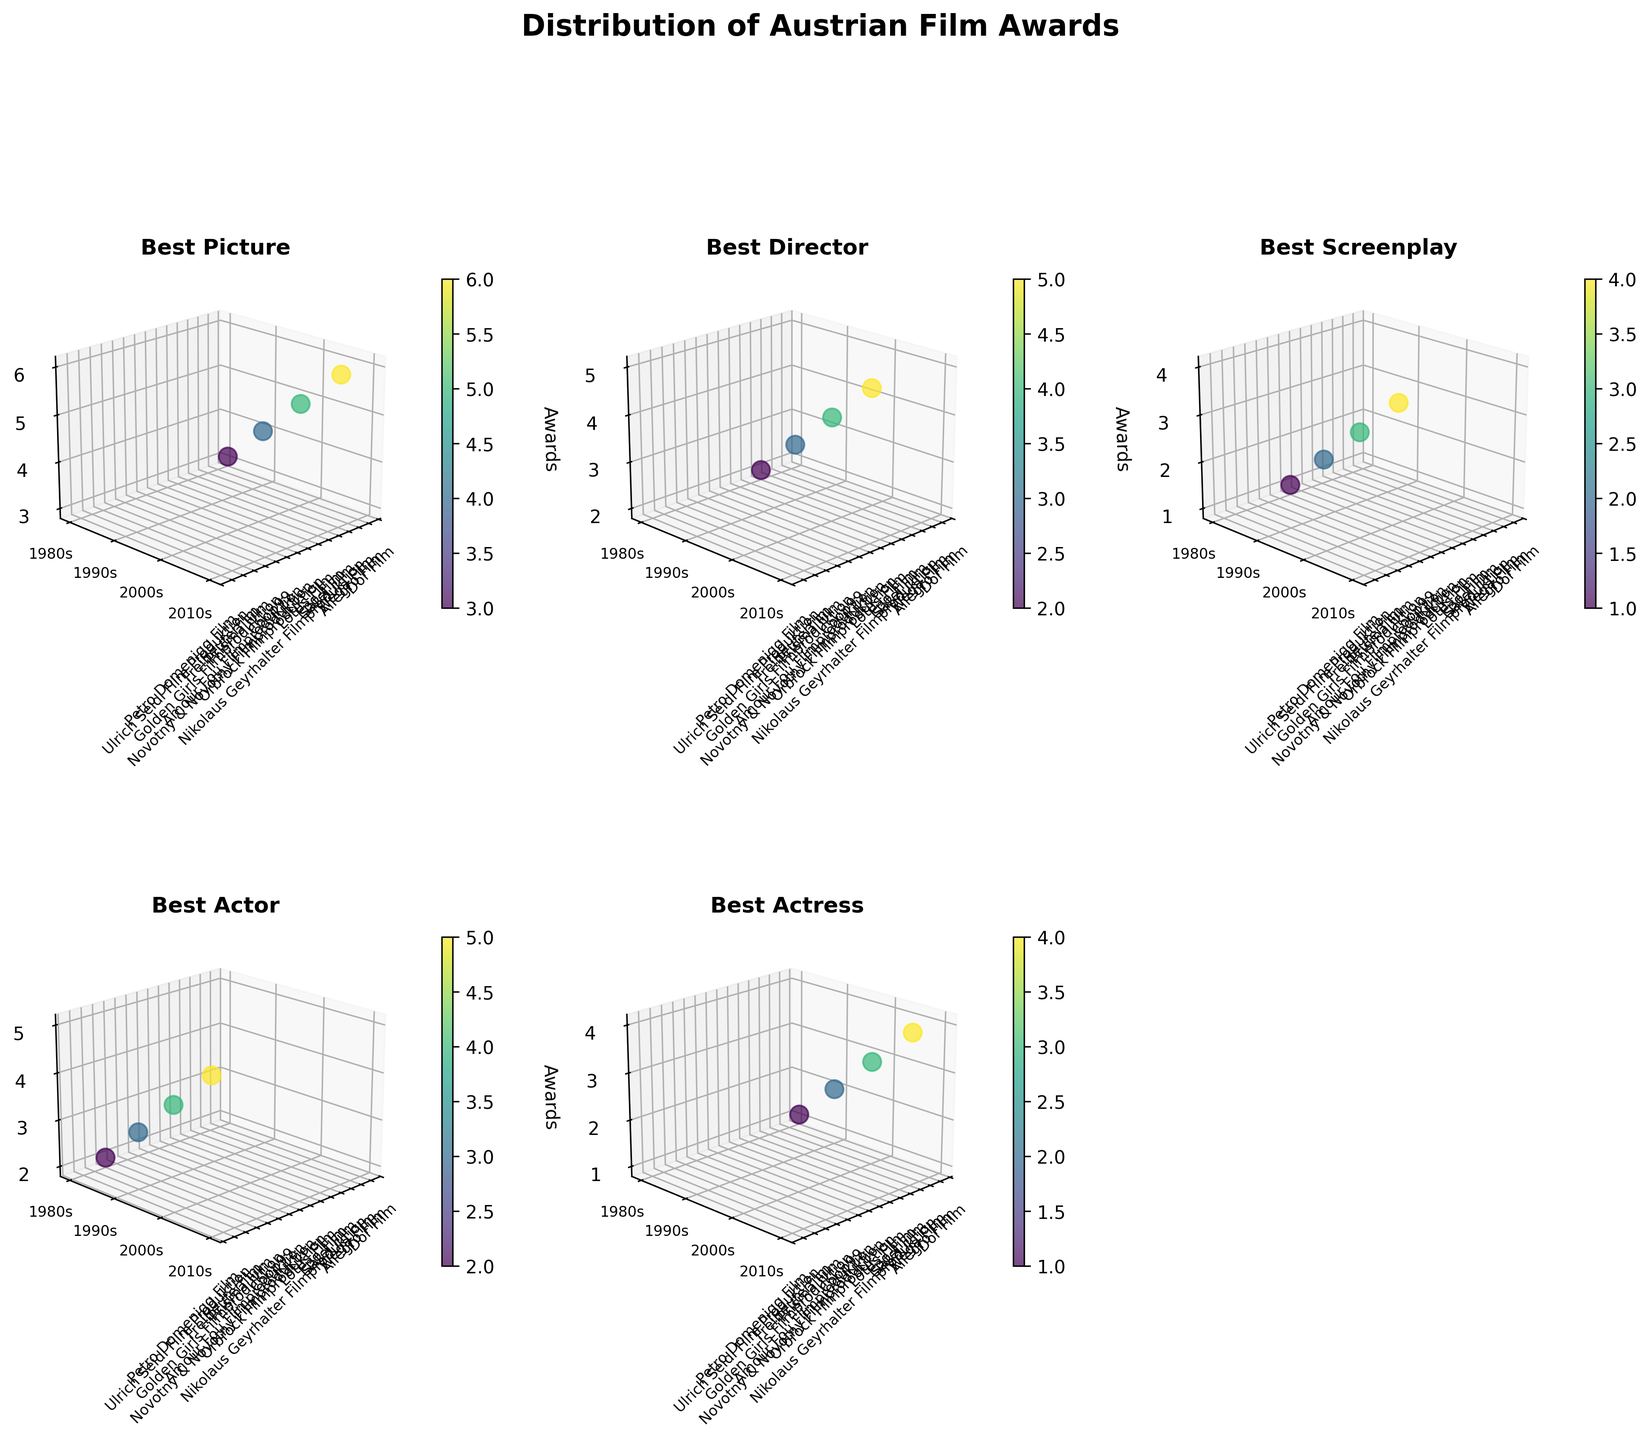What's the title of the figure? The title is typically located at the top center of the figure. For our plot, it is stated as "Distribution of Austrian Film Awards."
Answer: Distribution of Austrian Film Awards Which category has the awards distributed across four production studios? By looking at the subplots, we find that categories like Best Picture, Best Director, Best Screenplay, Best Actor, and Best Actress all have awards distributed across four different production studios.
Answer: Best Picture, Best Director, Best Screenplay, Best Actor, Best Actress In the Best Picture category, which decade has the highest number of awards? We look at the Best Picture subplot and identify the decade with the highest z-values. The 2010s show the highest awards count of 6.
Answer: 2010s What is the total number of awards received by Wega Film across all categories? In the plots, Wega Film has entries in Best Picture, Best Actress; the award counts are 5 and 3 respectively. Summing these values gives 8.
Answer: 8 Which category awards were most frequently won by Dor Film? Checking all relevant subplots with Dor Film, we observe it appears in Best Picture (1980s) and Best Actress (1980s). Noting the awards counts, Best Picture (3) is higher than Best Actress (1).
Answer: Best Picture How does the awards count for the Best Actor category change from the 1980s to the 2010s? In the Best Actor subplot, we find the awards for the 1980s and 2010s, which are 2 and 5 respectively. The difference is calculated by subtracting 2 from 5.
Answer: Increased by 3 Among Coop99, Allegro Film, and Lotus Film, which studio has the lowest total awards across all decades? Summing the awards for Coop99 (3 in Best Screenplay), Allegro Film (4 in Best Picture and 2 in Best Actress for a total of 6), and Lotus Film (4 in Best Director) we find Coop99 has the lowest total of 3.
Answer: Coop99 In which category do we observe a studio having consistent growth in the number of awards over different decades? Observing the subplots, particularly Best Picture, Nikolaus Geyrhalter Filmproduktion shows consistent growth over the decades (1980s: 0, 1990s: 0, 2000s: 0, 2010s: 6).
Answer: Best Picture Which category and decade combination has the lowest number of awards, and what is the count? Scanning all subplots by decade, we find that Best Screenplay in the 1980s has the least number of awards, which is 1.
Answer: Best Screenplay, 1980s, 1 Which production studio received the most awards in the 2000s, and in which categories? Reviewing the plots for the 2000s across categories reveals that Wega Film received the most awards in the 2000s (5 in Best Picture and 3 in Best Actress). Thus, totaling 8.
Answer: Wega Film, Best Picture and Best Actress 